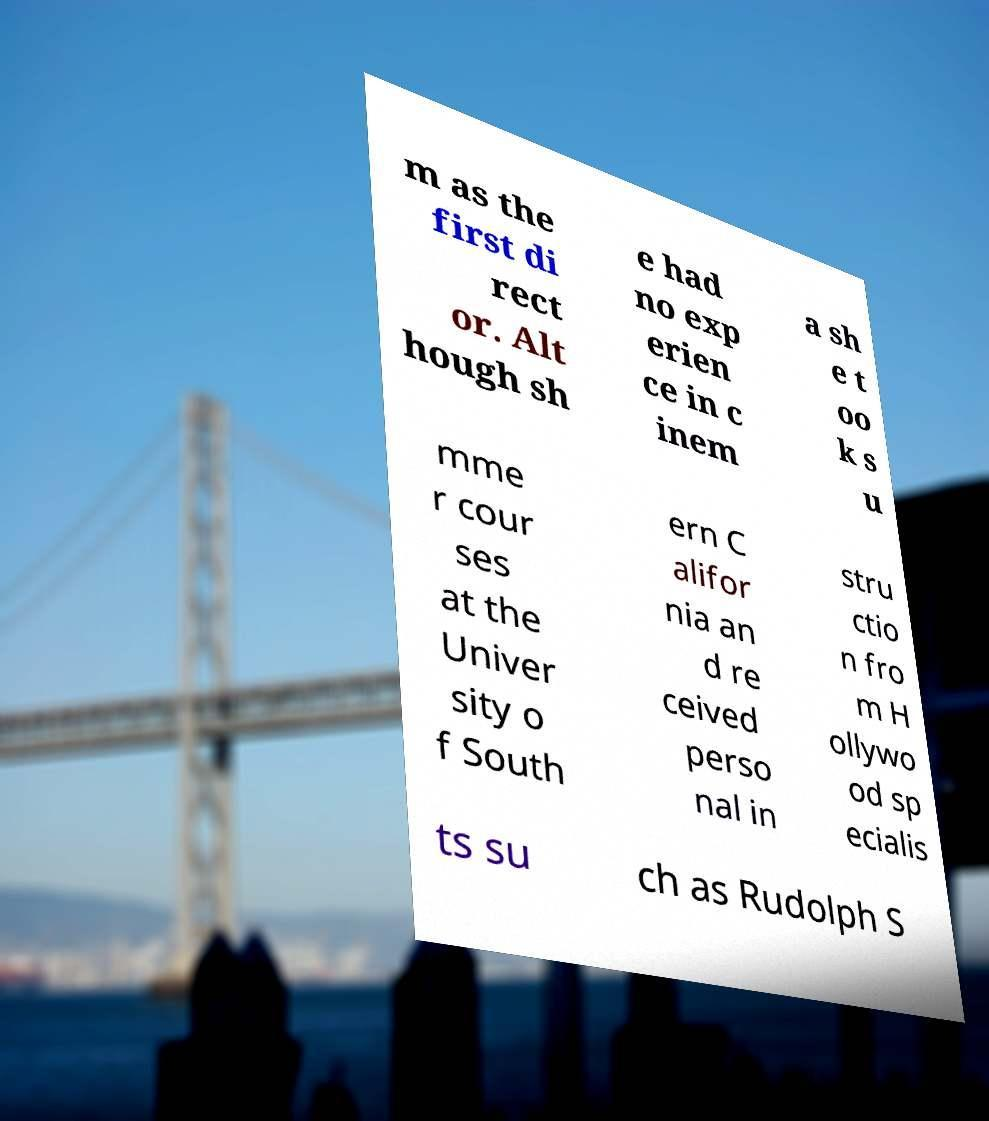Can you accurately transcribe the text from the provided image for me? m as the first di rect or. Alt hough sh e had no exp erien ce in c inem a sh e t oo k s u mme r cour ses at the Univer sity o f South ern C alifor nia an d re ceived perso nal in stru ctio n fro m H ollywo od sp ecialis ts su ch as Rudolph S 